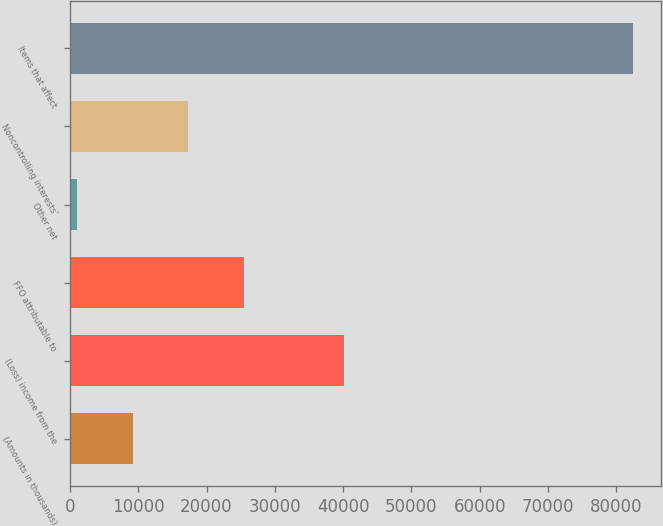Convert chart. <chart><loc_0><loc_0><loc_500><loc_500><bar_chart><fcel>(Amounts in thousands)<fcel>(Loss) income from the<fcel>FFO attributable to<fcel>Other net<fcel>Noncontrolling interests'<fcel>Items that affect<nl><fcel>9161.9<fcel>40120<fcel>25457.7<fcel>1014<fcel>17309.8<fcel>82493<nl></chart> 